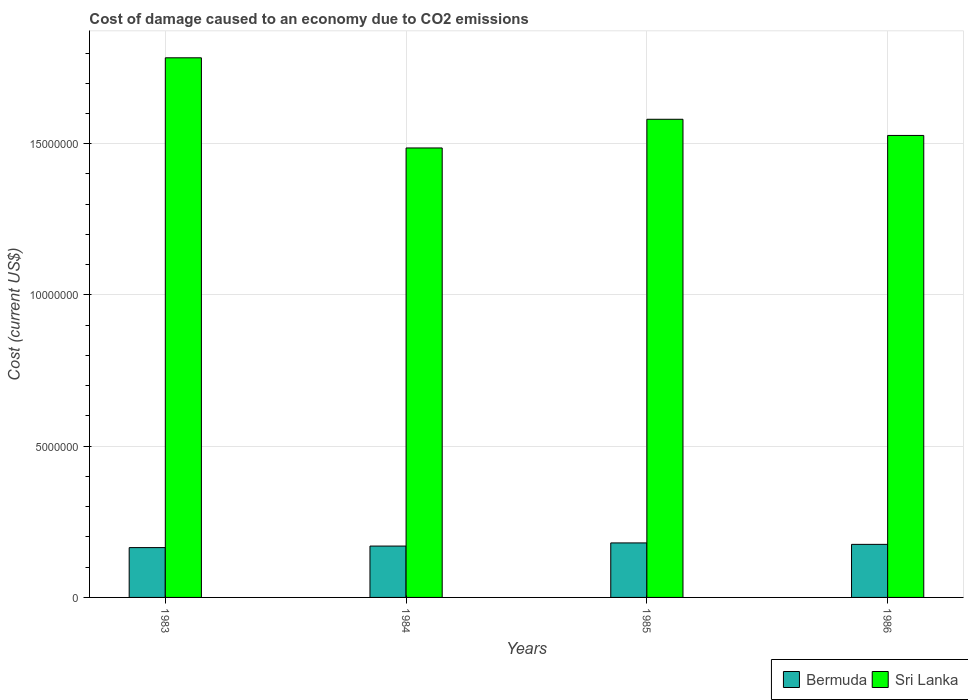How many different coloured bars are there?
Provide a short and direct response. 2. Are the number of bars per tick equal to the number of legend labels?
Provide a succinct answer. Yes. How many bars are there on the 1st tick from the left?
Provide a succinct answer. 2. What is the label of the 4th group of bars from the left?
Keep it short and to the point. 1986. In how many cases, is the number of bars for a given year not equal to the number of legend labels?
Your response must be concise. 0. What is the cost of damage caused due to CO2 emissisons in Bermuda in 1986?
Provide a succinct answer. 1.75e+06. Across all years, what is the maximum cost of damage caused due to CO2 emissisons in Bermuda?
Your response must be concise. 1.80e+06. Across all years, what is the minimum cost of damage caused due to CO2 emissisons in Bermuda?
Keep it short and to the point. 1.65e+06. In which year was the cost of damage caused due to CO2 emissisons in Sri Lanka maximum?
Give a very brief answer. 1983. What is the total cost of damage caused due to CO2 emissisons in Bermuda in the graph?
Your answer should be very brief. 6.90e+06. What is the difference between the cost of damage caused due to CO2 emissisons in Bermuda in 1984 and that in 1985?
Give a very brief answer. -1.04e+05. What is the difference between the cost of damage caused due to CO2 emissisons in Bermuda in 1983 and the cost of damage caused due to CO2 emissisons in Sri Lanka in 1985?
Keep it short and to the point. -1.42e+07. What is the average cost of damage caused due to CO2 emissisons in Bermuda per year?
Your response must be concise. 1.73e+06. In the year 1986, what is the difference between the cost of damage caused due to CO2 emissisons in Bermuda and cost of damage caused due to CO2 emissisons in Sri Lanka?
Keep it short and to the point. -1.35e+07. In how many years, is the cost of damage caused due to CO2 emissisons in Bermuda greater than 5000000 US$?
Your answer should be compact. 0. What is the ratio of the cost of damage caused due to CO2 emissisons in Sri Lanka in 1984 to that in 1986?
Offer a very short reply. 0.97. Is the cost of damage caused due to CO2 emissisons in Bermuda in 1983 less than that in 1984?
Make the answer very short. Yes. Is the difference between the cost of damage caused due to CO2 emissisons in Bermuda in 1985 and 1986 greater than the difference between the cost of damage caused due to CO2 emissisons in Sri Lanka in 1985 and 1986?
Keep it short and to the point. No. What is the difference between the highest and the second highest cost of damage caused due to CO2 emissisons in Bermuda?
Make the answer very short. 4.79e+04. What is the difference between the highest and the lowest cost of damage caused due to CO2 emissisons in Bermuda?
Provide a succinct answer. 1.55e+05. In how many years, is the cost of damage caused due to CO2 emissisons in Bermuda greater than the average cost of damage caused due to CO2 emissisons in Bermuda taken over all years?
Make the answer very short. 2. What does the 1st bar from the left in 1986 represents?
Provide a short and direct response. Bermuda. What does the 1st bar from the right in 1985 represents?
Keep it short and to the point. Sri Lanka. How many bars are there?
Provide a succinct answer. 8. How many years are there in the graph?
Your answer should be compact. 4. What is the difference between two consecutive major ticks on the Y-axis?
Provide a short and direct response. 5.00e+06. How many legend labels are there?
Provide a short and direct response. 2. What is the title of the graph?
Your answer should be very brief. Cost of damage caused to an economy due to CO2 emissions. Does "Sierra Leone" appear as one of the legend labels in the graph?
Provide a succinct answer. No. What is the label or title of the Y-axis?
Ensure brevity in your answer.  Cost (current US$). What is the Cost (current US$) in Bermuda in 1983?
Offer a very short reply. 1.65e+06. What is the Cost (current US$) in Sri Lanka in 1983?
Your answer should be very brief. 1.78e+07. What is the Cost (current US$) in Bermuda in 1984?
Your response must be concise. 1.70e+06. What is the Cost (current US$) in Sri Lanka in 1984?
Your answer should be very brief. 1.49e+07. What is the Cost (current US$) of Bermuda in 1985?
Make the answer very short. 1.80e+06. What is the Cost (current US$) of Sri Lanka in 1985?
Offer a terse response. 1.58e+07. What is the Cost (current US$) in Bermuda in 1986?
Keep it short and to the point. 1.75e+06. What is the Cost (current US$) in Sri Lanka in 1986?
Ensure brevity in your answer.  1.53e+07. Across all years, what is the maximum Cost (current US$) of Bermuda?
Provide a succinct answer. 1.80e+06. Across all years, what is the maximum Cost (current US$) of Sri Lanka?
Provide a succinct answer. 1.78e+07. Across all years, what is the minimum Cost (current US$) in Bermuda?
Your answer should be very brief. 1.65e+06. Across all years, what is the minimum Cost (current US$) of Sri Lanka?
Give a very brief answer. 1.49e+07. What is the total Cost (current US$) in Bermuda in the graph?
Your answer should be very brief. 6.90e+06. What is the total Cost (current US$) of Sri Lanka in the graph?
Provide a succinct answer. 6.38e+07. What is the difference between the Cost (current US$) of Bermuda in 1983 and that in 1984?
Ensure brevity in your answer.  -5.04e+04. What is the difference between the Cost (current US$) in Sri Lanka in 1983 and that in 1984?
Ensure brevity in your answer.  2.98e+06. What is the difference between the Cost (current US$) in Bermuda in 1983 and that in 1985?
Your answer should be compact. -1.55e+05. What is the difference between the Cost (current US$) of Sri Lanka in 1983 and that in 1985?
Your answer should be very brief. 2.03e+06. What is the difference between the Cost (current US$) in Bermuda in 1983 and that in 1986?
Your answer should be very brief. -1.07e+05. What is the difference between the Cost (current US$) in Sri Lanka in 1983 and that in 1986?
Offer a very short reply. 2.57e+06. What is the difference between the Cost (current US$) in Bermuda in 1984 and that in 1985?
Ensure brevity in your answer.  -1.04e+05. What is the difference between the Cost (current US$) of Sri Lanka in 1984 and that in 1985?
Provide a short and direct response. -9.49e+05. What is the difference between the Cost (current US$) in Bermuda in 1984 and that in 1986?
Your answer should be very brief. -5.63e+04. What is the difference between the Cost (current US$) of Sri Lanka in 1984 and that in 1986?
Offer a terse response. -4.14e+05. What is the difference between the Cost (current US$) in Bermuda in 1985 and that in 1986?
Your response must be concise. 4.79e+04. What is the difference between the Cost (current US$) of Sri Lanka in 1985 and that in 1986?
Provide a short and direct response. 5.35e+05. What is the difference between the Cost (current US$) of Bermuda in 1983 and the Cost (current US$) of Sri Lanka in 1984?
Provide a succinct answer. -1.32e+07. What is the difference between the Cost (current US$) in Bermuda in 1983 and the Cost (current US$) in Sri Lanka in 1985?
Offer a very short reply. -1.42e+07. What is the difference between the Cost (current US$) in Bermuda in 1983 and the Cost (current US$) in Sri Lanka in 1986?
Your answer should be compact. -1.36e+07. What is the difference between the Cost (current US$) in Bermuda in 1984 and the Cost (current US$) in Sri Lanka in 1985?
Your answer should be very brief. -1.41e+07. What is the difference between the Cost (current US$) of Bermuda in 1984 and the Cost (current US$) of Sri Lanka in 1986?
Give a very brief answer. -1.36e+07. What is the difference between the Cost (current US$) in Bermuda in 1985 and the Cost (current US$) in Sri Lanka in 1986?
Make the answer very short. -1.35e+07. What is the average Cost (current US$) in Bermuda per year?
Give a very brief answer. 1.73e+06. What is the average Cost (current US$) of Sri Lanka per year?
Provide a succinct answer. 1.59e+07. In the year 1983, what is the difference between the Cost (current US$) of Bermuda and Cost (current US$) of Sri Lanka?
Keep it short and to the point. -1.62e+07. In the year 1984, what is the difference between the Cost (current US$) of Bermuda and Cost (current US$) of Sri Lanka?
Provide a succinct answer. -1.32e+07. In the year 1985, what is the difference between the Cost (current US$) in Bermuda and Cost (current US$) in Sri Lanka?
Offer a very short reply. -1.40e+07. In the year 1986, what is the difference between the Cost (current US$) in Bermuda and Cost (current US$) in Sri Lanka?
Provide a succinct answer. -1.35e+07. What is the ratio of the Cost (current US$) in Bermuda in 1983 to that in 1984?
Offer a terse response. 0.97. What is the ratio of the Cost (current US$) of Sri Lanka in 1983 to that in 1984?
Offer a very short reply. 1.2. What is the ratio of the Cost (current US$) of Bermuda in 1983 to that in 1985?
Provide a succinct answer. 0.91. What is the ratio of the Cost (current US$) in Sri Lanka in 1983 to that in 1985?
Make the answer very short. 1.13. What is the ratio of the Cost (current US$) in Bermuda in 1983 to that in 1986?
Provide a succinct answer. 0.94. What is the ratio of the Cost (current US$) in Sri Lanka in 1983 to that in 1986?
Your answer should be very brief. 1.17. What is the ratio of the Cost (current US$) of Bermuda in 1984 to that in 1985?
Offer a very short reply. 0.94. What is the ratio of the Cost (current US$) in Bermuda in 1984 to that in 1986?
Make the answer very short. 0.97. What is the ratio of the Cost (current US$) in Sri Lanka in 1984 to that in 1986?
Your answer should be compact. 0.97. What is the ratio of the Cost (current US$) in Bermuda in 1985 to that in 1986?
Give a very brief answer. 1.03. What is the ratio of the Cost (current US$) in Sri Lanka in 1985 to that in 1986?
Your answer should be compact. 1.03. What is the difference between the highest and the second highest Cost (current US$) of Bermuda?
Give a very brief answer. 4.79e+04. What is the difference between the highest and the second highest Cost (current US$) in Sri Lanka?
Provide a succinct answer. 2.03e+06. What is the difference between the highest and the lowest Cost (current US$) in Bermuda?
Offer a terse response. 1.55e+05. What is the difference between the highest and the lowest Cost (current US$) of Sri Lanka?
Give a very brief answer. 2.98e+06. 